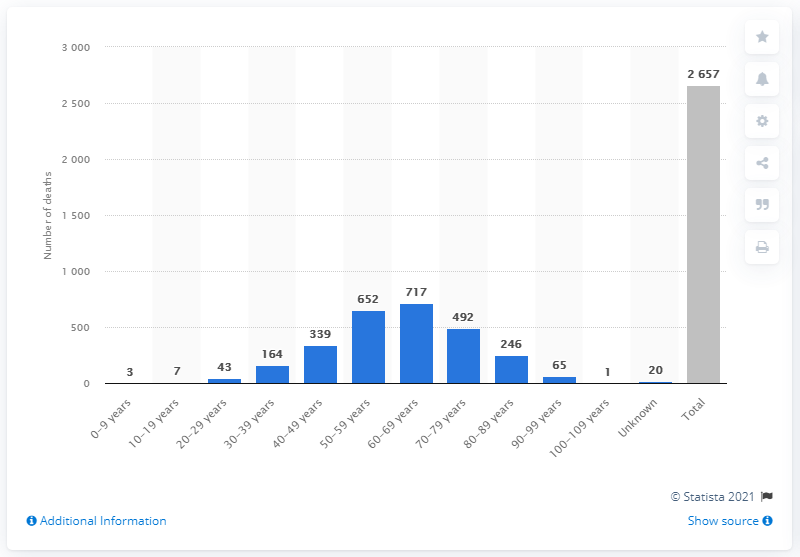Mention a couple of crucial points in this snapshot. According to recent data, a total of 652 individuals aged 50 to 59 have passed away due to the COVID-19 pandemic. 